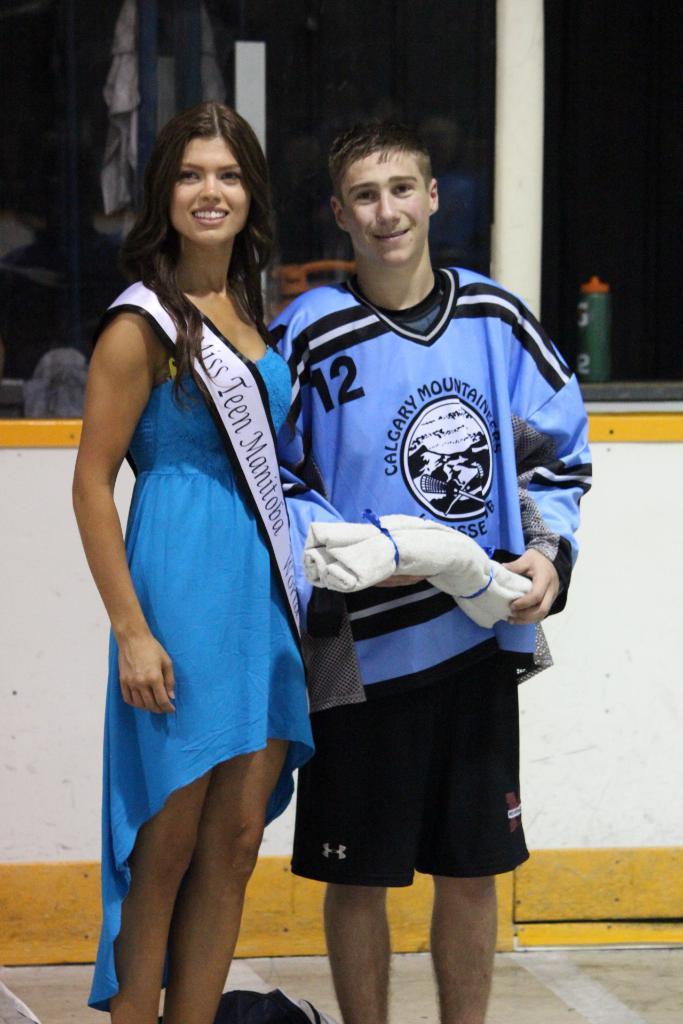Please provide a concise description of this image. In this image we can see a man and a lady standing and smiling. The man standing on the right is holding a cloth in his hand. In the background we can see a bottle placed on the wall and there are clothes. 